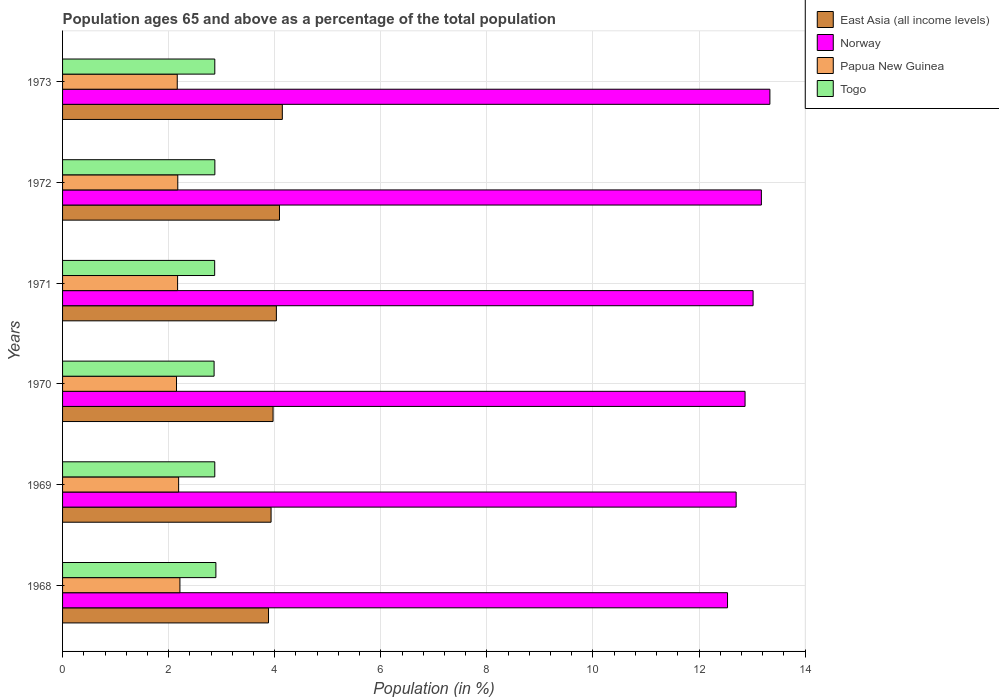How many different coloured bars are there?
Keep it short and to the point. 4. How many groups of bars are there?
Offer a terse response. 6. What is the label of the 3rd group of bars from the top?
Your answer should be very brief. 1971. In how many cases, is the number of bars for a given year not equal to the number of legend labels?
Provide a succinct answer. 0. What is the percentage of the population ages 65 and above in Papua New Guinea in 1969?
Offer a very short reply. 2.19. Across all years, what is the maximum percentage of the population ages 65 and above in Norway?
Give a very brief answer. 13.34. Across all years, what is the minimum percentage of the population ages 65 and above in Papua New Guinea?
Give a very brief answer. 2.15. In which year was the percentage of the population ages 65 and above in Papua New Guinea maximum?
Provide a succinct answer. 1968. In which year was the percentage of the population ages 65 and above in Norway minimum?
Offer a very short reply. 1968. What is the total percentage of the population ages 65 and above in Togo in the graph?
Provide a succinct answer. 17.23. What is the difference between the percentage of the population ages 65 and above in Norway in 1969 and that in 1972?
Give a very brief answer. -0.48. What is the difference between the percentage of the population ages 65 and above in Norway in 1969 and the percentage of the population ages 65 and above in Togo in 1968?
Make the answer very short. 9.81. What is the average percentage of the population ages 65 and above in Papua New Guinea per year?
Provide a short and direct response. 2.18. In the year 1972, what is the difference between the percentage of the population ages 65 and above in Papua New Guinea and percentage of the population ages 65 and above in East Asia (all income levels)?
Your response must be concise. -1.92. What is the ratio of the percentage of the population ages 65 and above in East Asia (all income levels) in 1969 to that in 1971?
Give a very brief answer. 0.98. Is the percentage of the population ages 65 and above in Togo in 1969 less than that in 1973?
Your answer should be very brief. Yes. What is the difference between the highest and the second highest percentage of the population ages 65 and above in Norway?
Provide a short and direct response. 0.16. What is the difference between the highest and the lowest percentage of the population ages 65 and above in Papua New Guinea?
Provide a succinct answer. 0.06. In how many years, is the percentage of the population ages 65 and above in Togo greater than the average percentage of the population ages 65 and above in Togo taken over all years?
Offer a very short reply. 2. Is the sum of the percentage of the population ages 65 and above in Papua New Guinea in 1968 and 1972 greater than the maximum percentage of the population ages 65 and above in Norway across all years?
Your response must be concise. No. Is it the case that in every year, the sum of the percentage of the population ages 65 and above in Togo and percentage of the population ages 65 and above in Papua New Guinea is greater than the sum of percentage of the population ages 65 and above in Norway and percentage of the population ages 65 and above in East Asia (all income levels)?
Your answer should be compact. No. What does the 2nd bar from the bottom in 1973 represents?
Ensure brevity in your answer.  Norway. Is it the case that in every year, the sum of the percentage of the population ages 65 and above in Papua New Guinea and percentage of the population ages 65 and above in Togo is greater than the percentage of the population ages 65 and above in Norway?
Give a very brief answer. No. How many bars are there?
Ensure brevity in your answer.  24. What is the difference between two consecutive major ticks on the X-axis?
Keep it short and to the point. 2. Are the values on the major ticks of X-axis written in scientific E-notation?
Your answer should be compact. No. Where does the legend appear in the graph?
Offer a very short reply. Top right. How many legend labels are there?
Offer a very short reply. 4. How are the legend labels stacked?
Make the answer very short. Vertical. What is the title of the graph?
Give a very brief answer. Population ages 65 and above as a percentage of the total population. Does "Gabon" appear as one of the legend labels in the graph?
Offer a very short reply. No. What is the label or title of the X-axis?
Your response must be concise. Population (in %). What is the label or title of the Y-axis?
Your answer should be compact. Years. What is the Population (in %) of East Asia (all income levels) in 1968?
Make the answer very short. 3.88. What is the Population (in %) in Norway in 1968?
Your answer should be compact. 12.54. What is the Population (in %) in Papua New Guinea in 1968?
Provide a succinct answer. 2.21. What is the Population (in %) of Togo in 1968?
Your response must be concise. 2.89. What is the Population (in %) of East Asia (all income levels) in 1969?
Your answer should be compact. 3.93. What is the Population (in %) in Norway in 1969?
Your answer should be compact. 12.7. What is the Population (in %) of Papua New Guinea in 1969?
Your answer should be very brief. 2.19. What is the Population (in %) in Togo in 1969?
Give a very brief answer. 2.87. What is the Population (in %) of East Asia (all income levels) in 1970?
Ensure brevity in your answer.  3.97. What is the Population (in %) of Norway in 1970?
Provide a short and direct response. 12.87. What is the Population (in %) of Papua New Guinea in 1970?
Offer a terse response. 2.15. What is the Population (in %) of Togo in 1970?
Give a very brief answer. 2.86. What is the Population (in %) of East Asia (all income levels) in 1971?
Keep it short and to the point. 4.03. What is the Population (in %) in Norway in 1971?
Your answer should be very brief. 13.02. What is the Population (in %) in Papua New Guinea in 1971?
Your answer should be compact. 2.17. What is the Population (in %) of Togo in 1971?
Offer a terse response. 2.87. What is the Population (in %) in East Asia (all income levels) in 1972?
Ensure brevity in your answer.  4.09. What is the Population (in %) of Norway in 1972?
Ensure brevity in your answer.  13.17. What is the Population (in %) in Papua New Guinea in 1972?
Make the answer very short. 2.17. What is the Population (in %) of Togo in 1972?
Provide a succinct answer. 2.87. What is the Population (in %) of East Asia (all income levels) in 1973?
Offer a very short reply. 4.14. What is the Population (in %) in Norway in 1973?
Offer a terse response. 13.34. What is the Population (in %) of Papua New Guinea in 1973?
Your answer should be compact. 2.16. What is the Population (in %) of Togo in 1973?
Make the answer very short. 2.87. Across all years, what is the maximum Population (in %) of East Asia (all income levels)?
Make the answer very short. 4.14. Across all years, what is the maximum Population (in %) in Norway?
Offer a terse response. 13.34. Across all years, what is the maximum Population (in %) in Papua New Guinea?
Your answer should be compact. 2.21. Across all years, what is the maximum Population (in %) of Togo?
Provide a short and direct response. 2.89. Across all years, what is the minimum Population (in %) of East Asia (all income levels)?
Your answer should be very brief. 3.88. Across all years, what is the minimum Population (in %) of Norway?
Make the answer very short. 12.54. Across all years, what is the minimum Population (in %) of Papua New Guinea?
Your response must be concise. 2.15. Across all years, what is the minimum Population (in %) in Togo?
Make the answer very short. 2.86. What is the total Population (in %) in East Asia (all income levels) in the graph?
Give a very brief answer. 24.05. What is the total Population (in %) of Norway in the graph?
Your answer should be very brief. 77.63. What is the total Population (in %) of Papua New Guinea in the graph?
Keep it short and to the point. 13.05. What is the total Population (in %) in Togo in the graph?
Offer a terse response. 17.23. What is the difference between the Population (in %) in East Asia (all income levels) in 1968 and that in 1969?
Provide a succinct answer. -0.05. What is the difference between the Population (in %) of Norway in 1968 and that in 1969?
Your answer should be compact. -0.16. What is the difference between the Population (in %) of Papua New Guinea in 1968 and that in 1969?
Make the answer very short. 0.02. What is the difference between the Population (in %) in Togo in 1968 and that in 1969?
Ensure brevity in your answer.  0.02. What is the difference between the Population (in %) of East Asia (all income levels) in 1968 and that in 1970?
Your answer should be very brief. -0.09. What is the difference between the Population (in %) of Norway in 1968 and that in 1970?
Keep it short and to the point. -0.33. What is the difference between the Population (in %) in Papua New Guinea in 1968 and that in 1970?
Offer a very short reply. 0.06. What is the difference between the Population (in %) in Togo in 1968 and that in 1970?
Ensure brevity in your answer.  0.03. What is the difference between the Population (in %) of East Asia (all income levels) in 1968 and that in 1971?
Make the answer very short. -0.15. What is the difference between the Population (in %) in Norway in 1968 and that in 1971?
Ensure brevity in your answer.  -0.48. What is the difference between the Population (in %) in Papua New Guinea in 1968 and that in 1971?
Make the answer very short. 0.04. What is the difference between the Population (in %) in Togo in 1968 and that in 1971?
Offer a terse response. 0.02. What is the difference between the Population (in %) in East Asia (all income levels) in 1968 and that in 1972?
Your response must be concise. -0.21. What is the difference between the Population (in %) of Norway in 1968 and that in 1972?
Give a very brief answer. -0.64. What is the difference between the Population (in %) of Papua New Guinea in 1968 and that in 1972?
Provide a succinct answer. 0.04. What is the difference between the Population (in %) of Togo in 1968 and that in 1972?
Provide a succinct answer. 0.02. What is the difference between the Population (in %) in East Asia (all income levels) in 1968 and that in 1973?
Offer a terse response. -0.26. What is the difference between the Population (in %) in Norway in 1968 and that in 1973?
Provide a succinct answer. -0.8. What is the difference between the Population (in %) of Papua New Guinea in 1968 and that in 1973?
Offer a terse response. 0.05. What is the difference between the Population (in %) of Togo in 1968 and that in 1973?
Ensure brevity in your answer.  0.02. What is the difference between the Population (in %) of East Asia (all income levels) in 1969 and that in 1970?
Offer a terse response. -0.04. What is the difference between the Population (in %) in Norway in 1969 and that in 1970?
Your answer should be very brief. -0.17. What is the difference between the Population (in %) of Papua New Guinea in 1969 and that in 1970?
Make the answer very short. 0.04. What is the difference between the Population (in %) of Togo in 1969 and that in 1970?
Make the answer very short. 0.01. What is the difference between the Population (in %) in East Asia (all income levels) in 1969 and that in 1971?
Offer a very short reply. -0.1. What is the difference between the Population (in %) in Norway in 1969 and that in 1971?
Your answer should be compact. -0.32. What is the difference between the Population (in %) of Papua New Guinea in 1969 and that in 1971?
Offer a very short reply. 0.02. What is the difference between the Population (in %) in Togo in 1969 and that in 1971?
Give a very brief answer. 0. What is the difference between the Population (in %) in East Asia (all income levels) in 1969 and that in 1972?
Provide a short and direct response. -0.16. What is the difference between the Population (in %) in Norway in 1969 and that in 1972?
Offer a terse response. -0.48. What is the difference between the Population (in %) in Papua New Guinea in 1969 and that in 1972?
Provide a succinct answer. 0.02. What is the difference between the Population (in %) in Togo in 1969 and that in 1972?
Offer a terse response. -0. What is the difference between the Population (in %) in East Asia (all income levels) in 1969 and that in 1973?
Make the answer very short. -0.21. What is the difference between the Population (in %) in Norway in 1969 and that in 1973?
Offer a terse response. -0.64. What is the difference between the Population (in %) in Papua New Guinea in 1969 and that in 1973?
Your answer should be compact. 0.03. What is the difference between the Population (in %) in Togo in 1969 and that in 1973?
Give a very brief answer. -0. What is the difference between the Population (in %) in East Asia (all income levels) in 1970 and that in 1971?
Ensure brevity in your answer.  -0.06. What is the difference between the Population (in %) in Norway in 1970 and that in 1971?
Ensure brevity in your answer.  -0.15. What is the difference between the Population (in %) of Papua New Guinea in 1970 and that in 1971?
Provide a succinct answer. -0.02. What is the difference between the Population (in %) in Togo in 1970 and that in 1971?
Ensure brevity in your answer.  -0.01. What is the difference between the Population (in %) of East Asia (all income levels) in 1970 and that in 1972?
Your response must be concise. -0.12. What is the difference between the Population (in %) in Norway in 1970 and that in 1972?
Your answer should be compact. -0.31. What is the difference between the Population (in %) in Papua New Guinea in 1970 and that in 1972?
Your response must be concise. -0.02. What is the difference between the Population (in %) in Togo in 1970 and that in 1972?
Offer a terse response. -0.01. What is the difference between the Population (in %) of East Asia (all income levels) in 1970 and that in 1973?
Provide a short and direct response. -0.17. What is the difference between the Population (in %) of Norway in 1970 and that in 1973?
Offer a terse response. -0.47. What is the difference between the Population (in %) of Papua New Guinea in 1970 and that in 1973?
Offer a terse response. -0.01. What is the difference between the Population (in %) of Togo in 1970 and that in 1973?
Offer a terse response. -0.01. What is the difference between the Population (in %) in East Asia (all income levels) in 1971 and that in 1972?
Offer a terse response. -0.06. What is the difference between the Population (in %) of Norway in 1971 and that in 1972?
Provide a short and direct response. -0.16. What is the difference between the Population (in %) of Papua New Guinea in 1971 and that in 1972?
Make the answer very short. -0. What is the difference between the Population (in %) of Togo in 1971 and that in 1972?
Ensure brevity in your answer.  -0. What is the difference between the Population (in %) in East Asia (all income levels) in 1971 and that in 1973?
Offer a terse response. -0.11. What is the difference between the Population (in %) of Norway in 1971 and that in 1973?
Ensure brevity in your answer.  -0.32. What is the difference between the Population (in %) in Papua New Guinea in 1971 and that in 1973?
Make the answer very short. 0.01. What is the difference between the Population (in %) in Togo in 1971 and that in 1973?
Ensure brevity in your answer.  -0. What is the difference between the Population (in %) in East Asia (all income levels) in 1972 and that in 1973?
Keep it short and to the point. -0.05. What is the difference between the Population (in %) in Norway in 1972 and that in 1973?
Offer a terse response. -0.16. What is the difference between the Population (in %) of Papua New Guinea in 1972 and that in 1973?
Your response must be concise. 0.01. What is the difference between the Population (in %) in Togo in 1972 and that in 1973?
Offer a terse response. 0. What is the difference between the Population (in %) of East Asia (all income levels) in 1968 and the Population (in %) of Norway in 1969?
Your answer should be very brief. -8.82. What is the difference between the Population (in %) in East Asia (all income levels) in 1968 and the Population (in %) in Papua New Guinea in 1969?
Provide a succinct answer. 1.69. What is the difference between the Population (in %) of East Asia (all income levels) in 1968 and the Population (in %) of Togo in 1969?
Offer a terse response. 1.01. What is the difference between the Population (in %) in Norway in 1968 and the Population (in %) in Papua New Guinea in 1969?
Give a very brief answer. 10.35. What is the difference between the Population (in %) in Norway in 1968 and the Population (in %) in Togo in 1969?
Ensure brevity in your answer.  9.67. What is the difference between the Population (in %) in Papua New Guinea in 1968 and the Population (in %) in Togo in 1969?
Your answer should be compact. -0.66. What is the difference between the Population (in %) in East Asia (all income levels) in 1968 and the Population (in %) in Norway in 1970?
Keep it short and to the point. -8.98. What is the difference between the Population (in %) of East Asia (all income levels) in 1968 and the Population (in %) of Papua New Guinea in 1970?
Ensure brevity in your answer.  1.73. What is the difference between the Population (in %) of East Asia (all income levels) in 1968 and the Population (in %) of Togo in 1970?
Your answer should be very brief. 1.03. What is the difference between the Population (in %) in Norway in 1968 and the Population (in %) in Papua New Guinea in 1970?
Provide a succinct answer. 10.39. What is the difference between the Population (in %) of Norway in 1968 and the Population (in %) of Togo in 1970?
Give a very brief answer. 9.68. What is the difference between the Population (in %) in Papua New Guinea in 1968 and the Population (in %) in Togo in 1970?
Offer a very short reply. -0.64. What is the difference between the Population (in %) in East Asia (all income levels) in 1968 and the Population (in %) in Norway in 1971?
Keep it short and to the point. -9.14. What is the difference between the Population (in %) in East Asia (all income levels) in 1968 and the Population (in %) in Papua New Guinea in 1971?
Your answer should be compact. 1.71. What is the difference between the Population (in %) of East Asia (all income levels) in 1968 and the Population (in %) of Togo in 1971?
Give a very brief answer. 1.01. What is the difference between the Population (in %) in Norway in 1968 and the Population (in %) in Papua New Guinea in 1971?
Provide a short and direct response. 10.37. What is the difference between the Population (in %) in Norway in 1968 and the Population (in %) in Togo in 1971?
Provide a short and direct response. 9.67. What is the difference between the Population (in %) of Papua New Guinea in 1968 and the Population (in %) of Togo in 1971?
Offer a terse response. -0.66. What is the difference between the Population (in %) of East Asia (all income levels) in 1968 and the Population (in %) of Norway in 1972?
Keep it short and to the point. -9.29. What is the difference between the Population (in %) of East Asia (all income levels) in 1968 and the Population (in %) of Papua New Guinea in 1972?
Provide a succinct answer. 1.71. What is the difference between the Population (in %) of East Asia (all income levels) in 1968 and the Population (in %) of Togo in 1972?
Your answer should be compact. 1.01. What is the difference between the Population (in %) of Norway in 1968 and the Population (in %) of Papua New Guinea in 1972?
Offer a terse response. 10.36. What is the difference between the Population (in %) of Norway in 1968 and the Population (in %) of Togo in 1972?
Provide a short and direct response. 9.67. What is the difference between the Population (in %) of Papua New Guinea in 1968 and the Population (in %) of Togo in 1972?
Your answer should be very brief. -0.66. What is the difference between the Population (in %) of East Asia (all income levels) in 1968 and the Population (in %) of Norway in 1973?
Provide a succinct answer. -9.45. What is the difference between the Population (in %) of East Asia (all income levels) in 1968 and the Population (in %) of Papua New Guinea in 1973?
Make the answer very short. 1.72. What is the difference between the Population (in %) of East Asia (all income levels) in 1968 and the Population (in %) of Togo in 1973?
Offer a very short reply. 1.01. What is the difference between the Population (in %) in Norway in 1968 and the Population (in %) in Papua New Guinea in 1973?
Keep it short and to the point. 10.37. What is the difference between the Population (in %) of Norway in 1968 and the Population (in %) of Togo in 1973?
Keep it short and to the point. 9.67. What is the difference between the Population (in %) of Papua New Guinea in 1968 and the Population (in %) of Togo in 1973?
Keep it short and to the point. -0.66. What is the difference between the Population (in %) in East Asia (all income levels) in 1969 and the Population (in %) in Norway in 1970?
Ensure brevity in your answer.  -8.94. What is the difference between the Population (in %) of East Asia (all income levels) in 1969 and the Population (in %) of Papua New Guinea in 1970?
Provide a short and direct response. 1.78. What is the difference between the Population (in %) of East Asia (all income levels) in 1969 and the Population (in %) of Togo in 1970?
Your answer should be compact. 1.07. What is the difference between the Population (in %) in Norway in 1969 and the Population (in %) in Papua New Guinea in 1970?
Give a very brief answer. 10.55. What is the difference between the Population (in %) in Norway in 1969 and the Population (in %) in Togo in 1970?
Provide a short and direct response. 9.84. What is the difference between the Population (in %) in Papua New Guinea in 1969 and the Population (in %) in Togo in 1970?
Provide a short and direct response. -0.67. What is the difference between the Population (in %) of East Asia (all income levels) in 1969 and the Population (in %) of Norway in 1971?
Your answer should be compact. -9.09. What is the difference between the Population (in %) in East Asia (all income levels) in 1969 and the Population (in %) in Papua New Guinea in 1971?
Keep it short and to the point. 1.76. What is the difference between the Population (in %) of East Asia (all income levels) in 1969 and the Population (in %) of Togo in 1971?
Provide a short and direct response. 1.06. What is the difference between the Population (in %) of Norway in 1969 and the Population (in %) of Papua New Guinea in 1971?
Offer a very short reply. 10.53. What is the difference between the Population (in %) of Norway in 1969 and the Population (in %) of Togo in 1971?
Your answer should be compact. 9.83. What is the difference between the Population (in %) in Papua New Guinea in 1969 and the Population (in %) in Togo in 1971?
Provide a succinct answer. -0.68. What is the difference between the Population (in %) in East Asia (all income levels) in 1969 and the Population (in %) in Norway in 1972?
Offer a terse response. -9.24. What is the difference between the Population (in %) in East Asia (all income levels) in 1969 and the Population (in %) in Papua New Guinea in 1972?
Provide a short and direct response. 1.76. What is the difference between the Population (in %) in East Asia (all income levels) in 1969 and the Population (in %) in Togo in 1972?
Your answer should be very brief. 1.06. What is the difference between the Population (in %) of Norway in 1969 and the Population (in %) of Papua New Guinea in 1972?
Offer a very short reply. 10.53. What is the difference between the Population (in %) of Norway in 1969 and the Population (in %) of Togo in 1972?
Make the answer very short. 9.83. What is the difference between the Population (in %) of Papua New Guinea in 1969 and the Population (in %) of Togo in 1972?
Give a very brief answer. -0.68. What is the difference between the Population (in %) of East Asia (all income levels) in 1969 and the Population (in %) of Norway in 1973?
Offer a terse response. -9.4. What is the difference between the Population (in %) of East Asia (all income levels) in 1969 and the Population (in %) of Papua New Guinea in 1973?
Offer a very short reply. 1.77. What is the difference between the Population (in %) in East Asia (all income levels) in 1969 and the Population (in %) in Togo in 1973?
Your answer should be compact. 1.06. What is the difference between the Population (in %) in Norway in 1969 and the Population (in %) in Papua New Guinea in 1973?
Make the answer very short. 10.54. What is the difference between the Population (in %) of Norway in 1969 and the Population (in %) of Togo in 1973?
Keep it short and to the point. 9.83. What is the difference between the Population (in %) in Papua New Guinea in 1969 and the Population (in %) in Togo in 1973?
Your answer should be very brief. -0.68. What is the difference between the Population (in %) in East Asia (all income levels) in 1970 and the Population (in %) in Norway in 1971?
Provide a short and direct response. -9.05. What is the difference between the Population (in %) in East Asia (all income levels) in 1970 and the Population (in %) in Papua New Guinea in 1971?
Offer a very short reply. 1.8. What is the difference between the Population (in %) of East Asia (all income levels) in 1970 and the Population (in %) of Togo in 1971?
Offer a terse response. 1.1. What is the difference between the Population (in %) in Norway in 1970 and the Population (in %) in Papua New Guinea in 1971?
Give a very brief answer. 10.7. What is the difference between the Population (in %) in Norway in 1970 and the Population (in %) in Togo in 1971?
Provide a succinct answer. 10. What is the difference between the Population (in %) in Papua New Guinea in 1970 and the Population (in %) in Togo in 1971?
Offer a very short reply. -0.72. What is the difference between the Population (in %) of East Asia (all income levels) in 1970 and the Population (in %) of Norway in 1972?
Make the answer very short. -9.21. What is the difference between the Population (in %) of East Asia (all income levels) in 1970 and the Population (in %) of Papua New Guinea in 1972?
Make the answer very short. 1.8. What is the difference between the Population (in %) of East Asia (all income levels) in 1970 and the Population (in %) of Togo in 1972?
Your answer should be very brief. 1.1. What is the difference between the Population (in %) in Norway in 1970 and the Population (in %) in Papua New Guinea in 1972?
Provide a succinct answer. 10.7. What is the difference between the Population (in %) of Norway in 1970 and the Population (in %) of Togo in 1972?
Your response must be concise. 10. What is the difference between the Population (in %) of Papua New Guinea in 1970 and the Population (in %) of Togo in 1972?
Ensure brevity in your answer.  -0.72. What is the difference between the Population (in %) of East Asia (all income levels) in 1970 and the Population (in %) of Norway in 1973?
Your answer should be compact. -9.37. What is the difference between the Population (in %) in East Asia (all income levels) in 1970 and the Population (in %) in Papua New Guinea in 1973?
Give a very brief answer. 1.81. What is the difference between the Population (in %) of East Asia (all income levels) in 1970 and the Population (in %) of Togo in 1973?
Give a very brief answer. 1.1. What is the difference between the Population (in %) of Norway in 1970 and the Population (in %) of Papua New Guinea in 1973?
Provide a short and direct response. 10.71. What is the difference between the Population (in %) of Norway in 1970 and the Population (in %) of Togo in 1973?
Your response must be concise. 10. What is the difference between the Population (in %) in Papua New Guinea in 1970 and the Population (in %) in Togo in 1973?
Provide a succinct answer. -0.72. What is the difference between the Population (in %) of East Asia (all income levels) in 1971 and the Population (in %) of Norway in 1972?
Give a very brief answer. -9.14. What is the difference between the Population (in %) in East Asia (all income levels) in 1971 and the Population (in %) in Papua New Guinea in 1972?
Offer a terse response. 1.86. What is the difference between the Population (in %) of East Asia (all income levels) in 1971 and the Population (in %) of Togo in 1972?
Offer a terse response. 1.16. What is the difference between the Population (in %) of Norway in 1971 and the Population (in %) of Papua New Guinea in 1972?
Your answer should be compact. 10.85. What is the difference between the Population (in %) of Norway in 1971 and the Population (in %) of Togo in 1972?
Offer a very short reply. 10.15. What is the difference between the Population (in %) of Papua New Guinea in 1971 and the Population (in %) of Togo in 1972?
Ensure brevity in your answer.  -0.7. What is the difference between the Population (in %) in East Asia (all income levels) in 1971 and the Population (in %) in Norway in 1973?
Offer a very short reply. -9.3. What is the difference between the Population (in %) of East Asia (all income levels) in 1971 and the Population (in %) of Papua New Guinea in 1973?
Offer a very short reply. 1.87. What is the difference between the Population (in %) in East Asia (all income levels) in 1971 and the Population (in %) in Togo in 1973?
Offer a very short reply. 1.16. What is the difference between the Population (in %) of Norway in 1971 and the Population (in %) of Papua New Guinea in 1973?
Give a very brief answer. 10.86. What is the difference between the Population (in %) of Norway in 1971 and the Population (in %) of Togo in 1973?
Give a very brief answer. 10.15. What is the difference between the Population (in %) of Papua New Guinea in 1971 and the Population (in %) of Togo in 1973?
Your answer should be very brief. -0.7. What is the difference between the Population (in %) of East Asia (all income levels) in 1972 and the Population (in %) of Norway in 1973?
Keep it short and to the point. -9.25. What is the difference between the Population (in %) in East Asia (all income levels) in 1972 and the Population (in %) in Papua New Guinea in 1973?
Your answer should be compact. 1.93. What is the difference between the Population (in %) of East Asia (all income levels) in 1972 and the Population (in %) of Togo in 1973?
Provide a short and direct response. 1.22. What is the difference between the Population (in %) of Norway in 1972 and the Population (in %) of Papua New Guinea in 1973?
Your answer should be compact. 11.01. What is the difference between the Population (in %) in Norway in 1972 and the Population (in %) in Togo in 1973?
Make the answer very short. 10.3. What is the difference between the Population (in %) in Papua New Guinea in 1972 and the Population (in %) in Togo in 1973?
Give a very brief answer. -0.7. What is the average Population (in %) of East Asia (all income levels) per year?
Your answer should be compact. 4.01. What is the average Population (in %) in Norway per year?
Provide a short and direct response. 12.94. What is the average Population (in %) in Papua New Guinea per year?
Your response must be concise. 2.18. What is the average Population (in %) in Togo per year?
Keep it short and to the point. 2.87. In the year 1968, what is the difference between the Population (in %) of East Asia (all income levels) and Population (in %) of Norway?
Your response must be concise. -8.65. In the year 1968, what is the difference between the Population (in %) in East Asia (all income levels) and Population (in %) in Papua New Guinea?
Ensure brevity in your answer.  1.67. In the year 1968, what is the difference between the Population (in %) in Norway and Population (in %) in Papua New Guinea?
Provide a short and direct response. 10.32. In the year 1968, what is the difference between the Population (in %) in Norway and Population (in %) in Togo?
Provide a succinct answer. 9.65. In the year 1968, what is the difference between the Population (in %) in Papua New Guinea and Population (in %) in Togo?
Keep it short and to the point. -0.68. In the year 1969, what is the difference between the Population (in %) of East Asia (all income levels) and Population (in %) of Norway?
Your response must be concise. -8.77. In the year 1969, what is the difference between the Population (in %) in East Asia (all income levels) and Population (in %) in Papua New Guinea?
Provide a short and direct response. 1.74. In the year 1969, what is the difference between the Population (in %) of East Asia (all income levels) and Population (in %) of Togo?
Make the answer very short. 1.06. In the year 1969, what is the difference between the Population (in %) in Norway and Population (in %) in Papua New Guinea?
Keep it short and to the point. 10.51. In the year 1969, what is the difference between the Population (in %) of Norway and Population (in %) of Togo?
Ensure brevity in your answer.  9.83. In the year 1969, what is the difference between the Population (in %) in Papua New Guinea and Population (in %) in Togo?
Keep it short and to the point. -0.68. In the year 1970, what is the difference between the Population (in %) in East Asia (all income levels) and Population (in %) in Norway?
Your answer should be compact. -8.9. In the year 1970, what is the difference between the Population (in %) in East Asia (all income levels) and Population (in %) in Papua New Guinea?
Make the answer very short. 1.82. In the year 1970, what is the difference between the Population (in %) in East Asia (all income levels) and Population (in %) in Togo?
Provide a short and direct response. 1.11. In the year 1970, what is the difference between the Population (in %) of Norway and Population (in %) of Papua New Guinea?
Keep it short and to the point. 10.72. In the year 1970, what is the difference between the Population (in %) in Norway and Population (in %) in Togo?
Offer a very short reply. 10.01. In the year 1970, what is the difference between the Population (in %) in Papua New Guinea and Population (in %) in Togo?
Offer a very short reply. -0.71. In the year 1971, what is the difference between the Population (in %) of East Asia (all income levels) and Population (in %) of Norway?
Keep it short and to the point. -8.99. In the year 1971, what is the difference between the Population (in %) of East Asia (all income levels) and Population (in %) of Papua New Guinea?
Ensure brevity in your answer.  1.86. In the year 1971, what is the difference between the Population (in %) of East Asia (all income levels) and Population (in %) of Togo?
Make the answer very short. 1.16. In the year 1971, what is the difference between the Population (in %) in Norway and Population (in %) in Papua New Guinea?
Ensure brevity in your answer.  10.85. In the year 1971, what is the difference between the Population (in %) of Norway and Population (in %) of Togo?
Keep it short and to the point. 10.15. In the year 1971, what is the difference between the Population (in %) of Papua New Guinea and Population (in %) of Togo?
Offer a terse response. -0.7. In the year 1972, what is the difference between the Population (in %) of East Asia (all income levels) and Population (in %) of Norway?
Your answer should be very brief. -9.09. In the year 1972, what is the difference between the Population (in %) of East Asia (all income levels) and Population (in %) of Papua New Guinea?
Keep it short and to the point. 1.92. In the year 1972, what is the difference between the Population (in %) of East Asia (all income levels) and Population (in %) of Togo?
Provide a succinct answer. 1.22. In the year 1972, what is the difference between the Population (in %) of Norway and Population (in %) of Papua New Guinea?
Your response must be concise. 11. In the year 1972, what is the difference between the Population (in %) in Norway and Population (in %) in Togo?
Offer a very short reply. 10.3. In the year 1972, what is the difference between the Population (in %) of Papua New Guinea and Population (in %) of Togo?
Your response must be concise. -0.7. In the year 1973, what is the difference between the Population (in %) in East Asia (all income levels) and Population (in %) in Norway?
Your answer should be compact. -9.19. In the year 1973, what is the difference between the Population (in %) of East Asia (all income levels) and Population (in %) of Papua New Guinea?
Your answer should be compact. 1.98. In the year 1973, what is the difference between the Population (in %) in East Asia (all income levels) and Population (in %) in Togo?
Your answer should be very brief. 1.27. In the year 1973, what is the difference between the Population (in %) of Norway and Population (in %) of Papua New Guinea?
Keep it short and to the point. 11.17. In the year 1973, what is the difference between the Population (in %) in Norway and Population (in %) in Togo?
Provide a succinct answer. 10.47. In the year 1973, what is the difference between the Population (in %) in Papua New Guinea and Population (in %) in Togo?
Ensure brevity in your answer.  -0.71. What is the ratio of the Population (in %) of Norway in 1968 to that in 1969?
Give a very brief answer. 0.99. What is the ratio of the Population (in %) in Papua New Guinea in 1968 to that in 1969?
Your answer should be compact. 1.01. What is the ratio of the Population (in %) in Togo in 1968 to that in 1969?
Your answer should be very brief. 1.01. What is the ratio of the Population (in %) in East Asia (all income levels) in 1968 to that in 1970?
Your answer should be compact. 0.98. What is the ratio of the Population (in %) of Norway in 1968 to that in 1970?
Keep it short and to the point. 0.97. What is the ratio of the Population (in %) in Papua New Guinea in 1968 to that in 1970?
Your answer should be very brief. 1.03. What is the ratio of the Population (in %) of Togo in 1968 to that in 1970?
Your answer should be compact. 1.01. What is the ratio of the Population (in %) in East Asia (all income levels) in 1968 to that in 1971?
Your response must be concise. 0.96. What is the ratio of the Population (in %) of Papua New Guinea in 1968 to that in 1971?
Your answer should be compact. 1.02. What is the ratio of the Population (in %) of Togo in 1968 to that in 1971?
Your answer should be very brief. 1.01. What is the ratio of the Population (in %) of East Asia (all income levels) in 1968 to that in 1972?
Your answer should be very brief. 0.95. What is the ratio of the Population (in %) in Norway in 1968 to that in 1972?
Your answer should be very brief. 0.95. What is the ratio of the Population (in %) of Papua New Guinea in 1968 to that in 1972?
Offer a very short reply. 1.02. What is the ratio of the Population (in %) of Togo in 1968 to that in 1972?
Keep it short and to the point. 1.01. What is the ratio of the Population (in %) of East Asia (all income levels) in 1968 to that in 1973?
Provide a succinct answer. 0.94. What is the ratio of the Population (in %) of Norway in 1968 to that in 1973?
Offer a terse response. 0.94. What is the ratio of the Population (in %) of Papua New Guinea in 1968 to that in 1973?
Offer a terse response. 1.02. What is the ratio of the Population (in %) of Togo in 1968 to that in 1973?
Offer a terse response. 1.01. What is the ratio of the Population (in %) of East Asia (all income levels) in 1969 to that in 1970?
Provide a short and direct response. 0.99. What is the ratio of the Population (in %) of Papua New Guinea in 1969 to that in 1970?
Offer a terse response. 1.02. What is the ratio of the Population (in %) of East Asia (all income levels) in 1969 to that in 1971?
Keep it short and to the point. 0.98. What is the ratio of the Population (in %) of Norway in 1969 to that in 1971?
Keep it short and to the point. 0.98. What is the ratio of the Population (in %) in Papua New Guinea in 1969 to that in 1971?
Your answer should be very brief. 1.01. What is the ratio of the Population (in %) in East Asia (all income levels) in 1969 to that in 1972?
Give a very brief answer. 0.96. What is the ratio of the Population (in %) in Norway in 1969 to that in 1972?
Provide a short and direct response. 0.96. What is the ratio of the Population (in %) of Papua New Guinea in 1969 to that in 1972?
Provide a succinct answer. 1.01. What is the ratio of the Population (in %) of Togo in 1969 to that in 1972?
Provide a short and direct response. 1. What is the ratio of the Population (in %) in East Asia (all income levels) in 1969 to that in 1973?
Ensure brevity in your answer.  0.95. What is the ratio of the Population (in %) of Norway in 1969 to that in 1973?
Your answer should be very brief. 0.95. What is the ratio of the Population (in %) in East Asia (all income levels) in 1970 to that in 1971?
Offer a terse response. 0.98. What is the ratio of the Population (in %) of Norway in 1970 to that in 1971?
Ensure brevity in your answer.  0.99. What is the ratio of the Population (in %) in Papua New Guinea in 1970 to that in 1971?
Offer a terse response. 0.99. What is the ratio of the Population (in %) of East Asia (all income levels) in 1970 to that in 1972?
Give a very brief answer. 0.97. What is the ratio of the Population (in %) of Norway in 1970 to that in 1972?
Your response must be concise. 0.98. What is the ratio of the Population (in %) in East Asia (all income levels) in 1970 to that in 1973?
Offer a terse response. 0.96. What is the ratio of the Population (in %) in Norway in 1970 to that in 1973?
Keep it short and to the point. 0.96. What is the ratio of the Population (in %) of Papua New Guinea in 1970 to that in 1973?
Keep it short and to the point. 0.99. What is the ratio of the Population (in %) in East Asia (all income levels) in 1971 to that in 1972?
Offer a terse response. 0.99. What is the ratio of the Population (in %) in East Asia (all income levels) in 1971 to that in 1973?
Give a very brief answer. 0.97. What is the ratio of the Population (in %) in Norway in 1971 to that in 1973?
Provide a succinct answer. 0.98. What is the ratio of the Population (in %) of Papua New Guinea in 1971 to that in 1973?
Offer a terse response. 1. What is the ratio of the Population (in %) in Papua New Guinea in 1972 to that in 1973?
Your answer should be very brief. 1. What is the difference between the highest and the second highest Population (in %) in East Asia (all income levels)?
Your response must be concise. 0.05. What is the difference between the highest and the second highest Population (in %) in Norway?
Your answer should be very brief. 0.16. What is the difference between the highest and the second highest Population (in %) in Papua New Guinea?
Ensure brevity in your answer.  0.02. What is the difference between the highest and the second highest Population (in %) in Togo?
Your answer should be compact. 0.02. What is the difference between the highest and the lowest Population (in %) of East Asia (all income levels)?
Ensure brevity in your answer.  0.26. What is the difference between the highest and the lowest Population (in %) of Norway?
Offer a very short reply. 0.8. What is the difference between the highest and the lowest Population (in %) in Papua New Guinea?
Make the answer very short. 0.06. What is the difference between the highest and the lowest Population (in %) of Togo?
Provide a succinct answer. 0.03. 